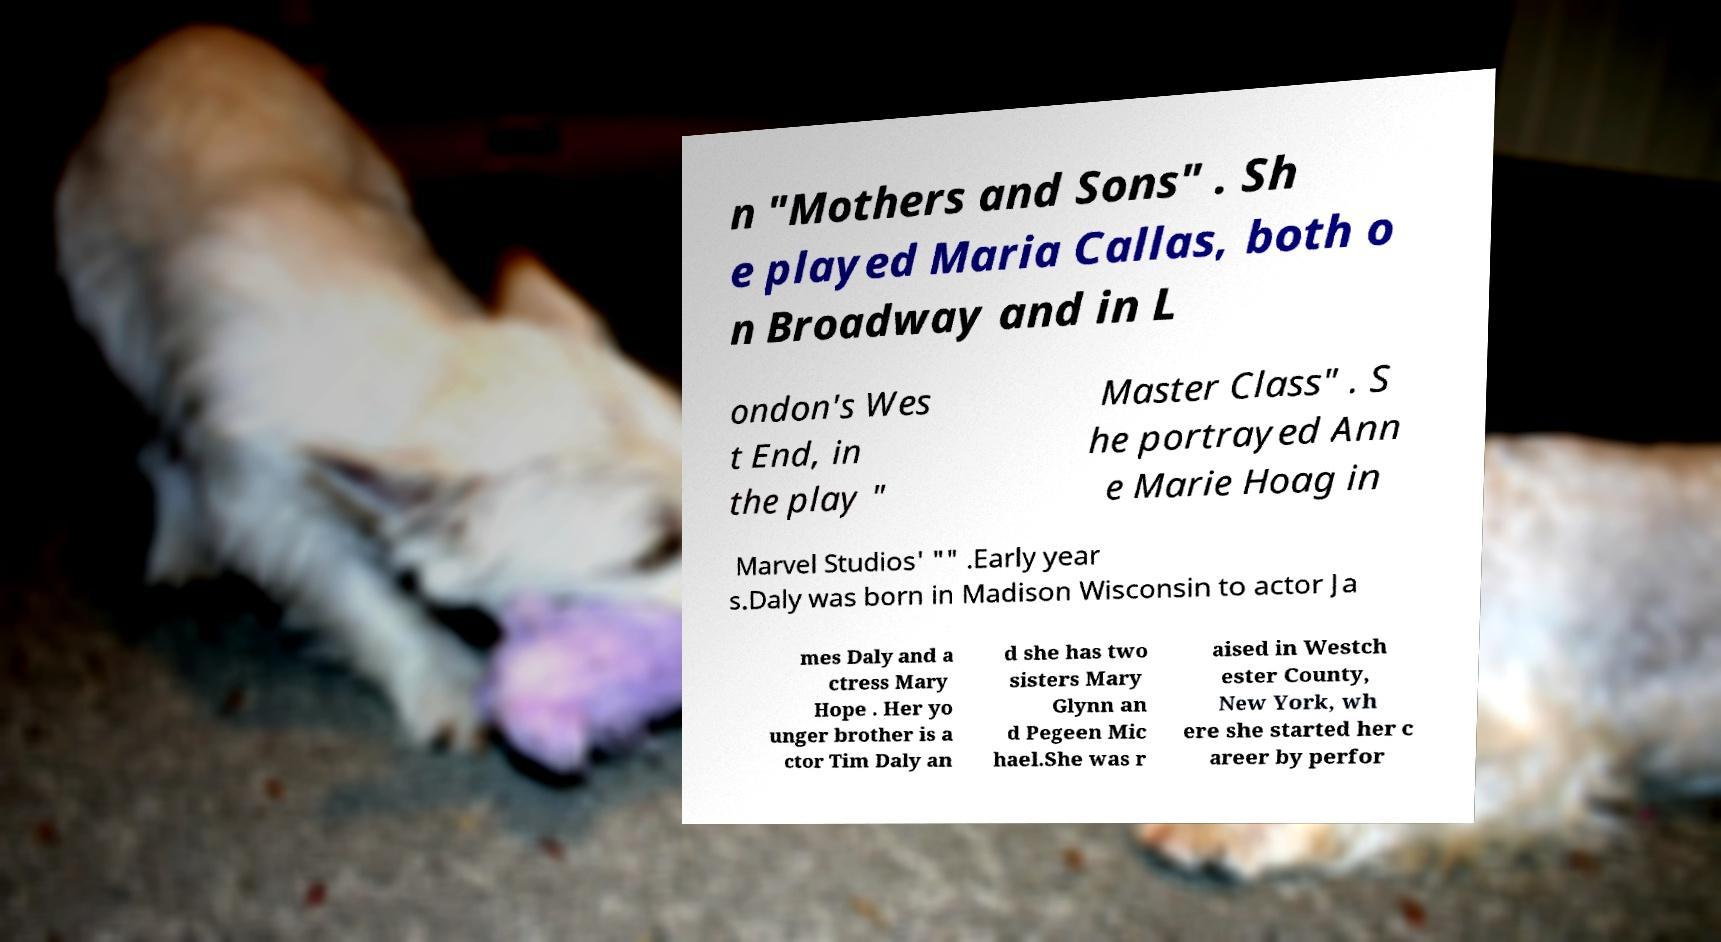I need the written content from this picture converted into text. Can you do that? n "Mothers and Sons" . Sh e played Maria Callas, both o n Broadway and in L ondon's Wes t End, in the play " Master Class" . S he portrayed Ann e Marie Hoag in Marvel Studios' "" .Early year s.Daly was born in Madison Wisconsin to actor Ja mes Daly and a ctress Mary Hope . Her yo unger brother is a ctor Tim Daly an d she has two sisters Mary Glynn an d Pegeen Mic hael.She was r aised in Westch ester County, New York, wh ere she started her c areer by perfor 